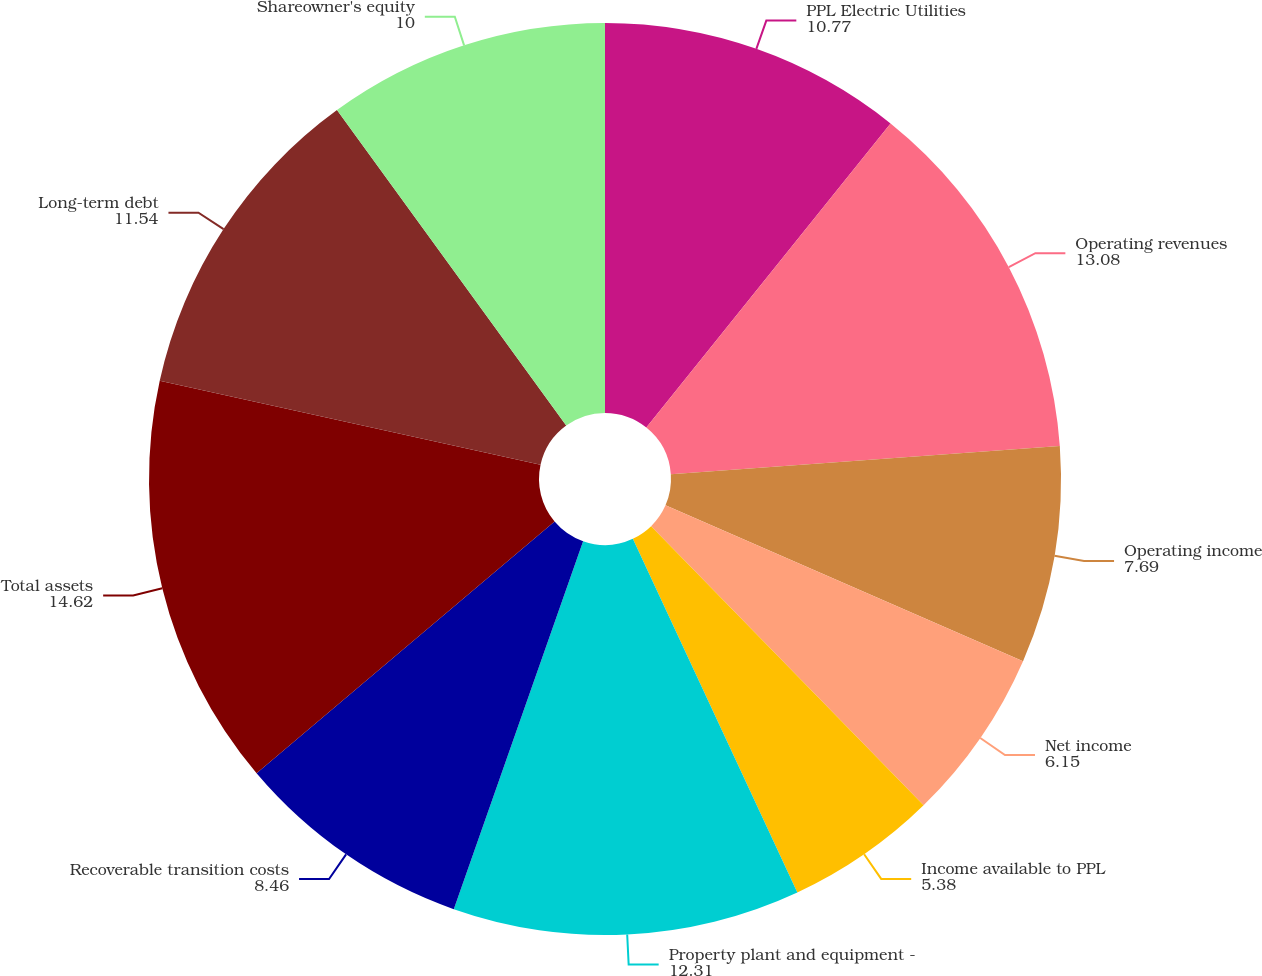<chart> <loc_0><loc_0><loc_500><loc_500><pie_chart><fcel>PPL Electric Utilities<fcel>Operating revenues<fcel>Operating income<fcel>Net income<fcel>Income available to PPL<fcel>Property plant and equipment -<fcel>Recoverable transition costs<fcel>Total assets<fcel>Long-term debt<fcel>Shareowner's equity<nl><fcel>10.77%<fcel>13.08%<fcel>7.69%<fcel>6.15%<fcel>5.38%<fcel>12.31%<fcel>8.46%<fcel>14.62%<fcel>11.54%<fcel>10.0%<nl></chart> 